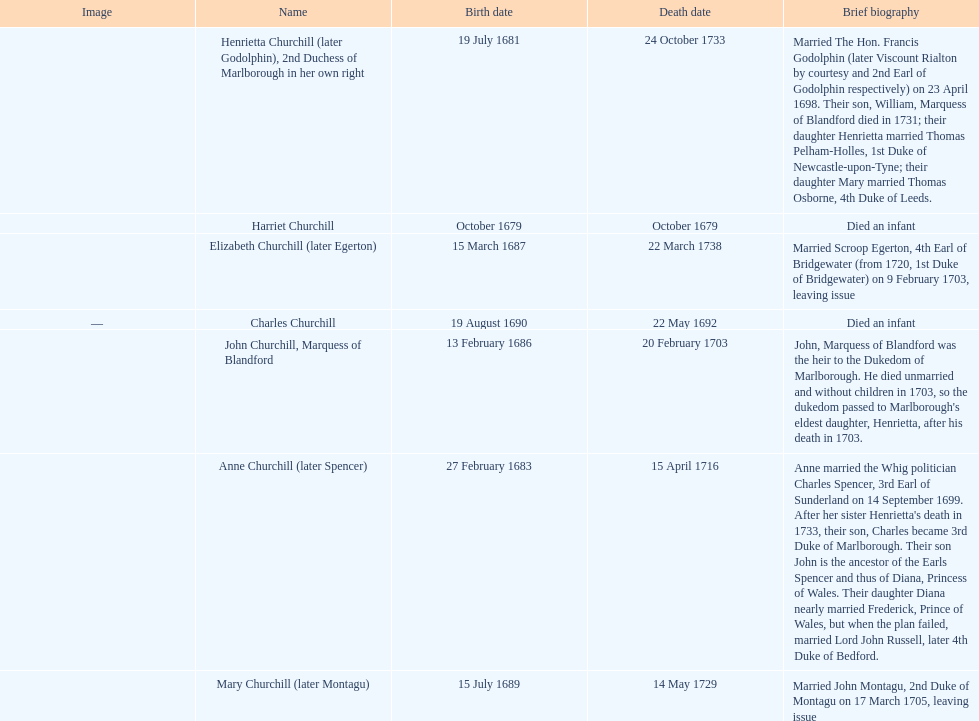What is the number of children sarah churchill had? 7. 